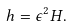Convert formula to latex. <formula><loc_0><loc_0><loc_500><loc_500>h = \epsilon ^ { 2 } H .</formula> 